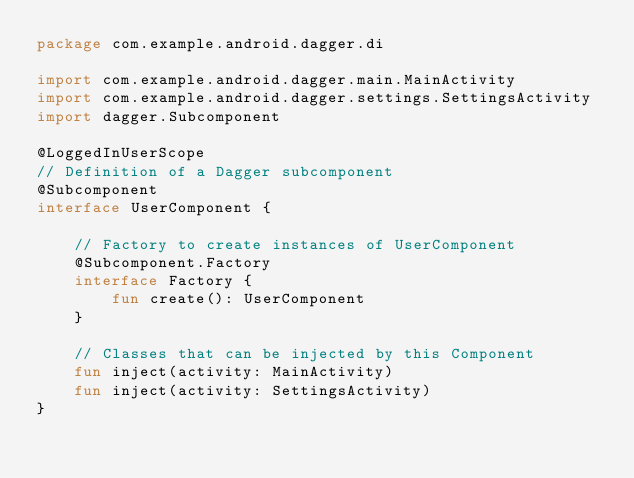<code> <loc_0><loc_0><loc_500><loc_500><_Kotlin_>package com.example.android.dagger.di

import com.example.android.dagger.main.MainActivity
import com.example.android.dagger.settings.SettingsActivity
import dagger.Subcomponent

@LoggedInUserScope
// Definition of a Dagger subcomponent
@Subcomponent
interface UserComponent {

    // Factory to create instances of UserComponent
    @Subcomponent.Factory
    interface Factory {
        fun create(): UserComponent
    }

    // Classes that can be injected by this Component
    fun inject(activity: MainActivity)
    fun inject(activity: SettingsActivity)
}</code> 